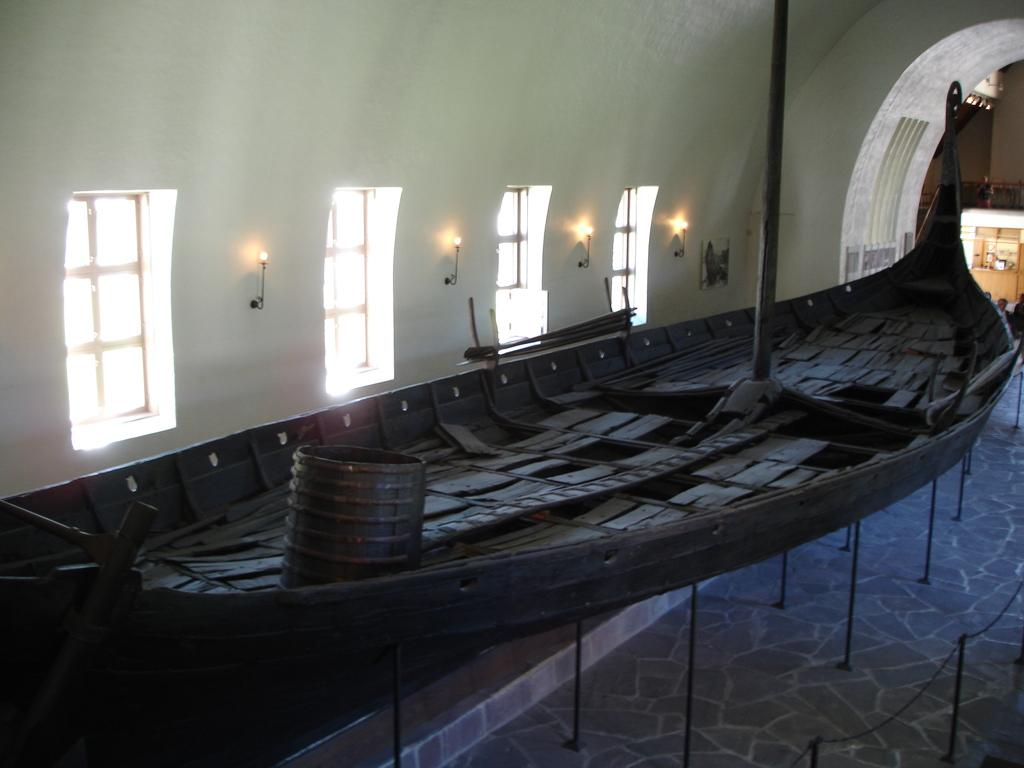What is the main object in the image? There is a boat on a stand in the image. What features can be seen in the middle of the image? There are windows and lights in the middle of the image. Where is the barricade stand located in the image? The barricade stand is in the bottom right of the image. What type of peace symbol can be seen on the boat in the image? There is no peace symbol present on the boat in the image. Can you tell me how many volleyballs are visible in the image? There are no volleyballs visible in the image. Is there a basketball court in the image? There is no basketball court present in the image. 